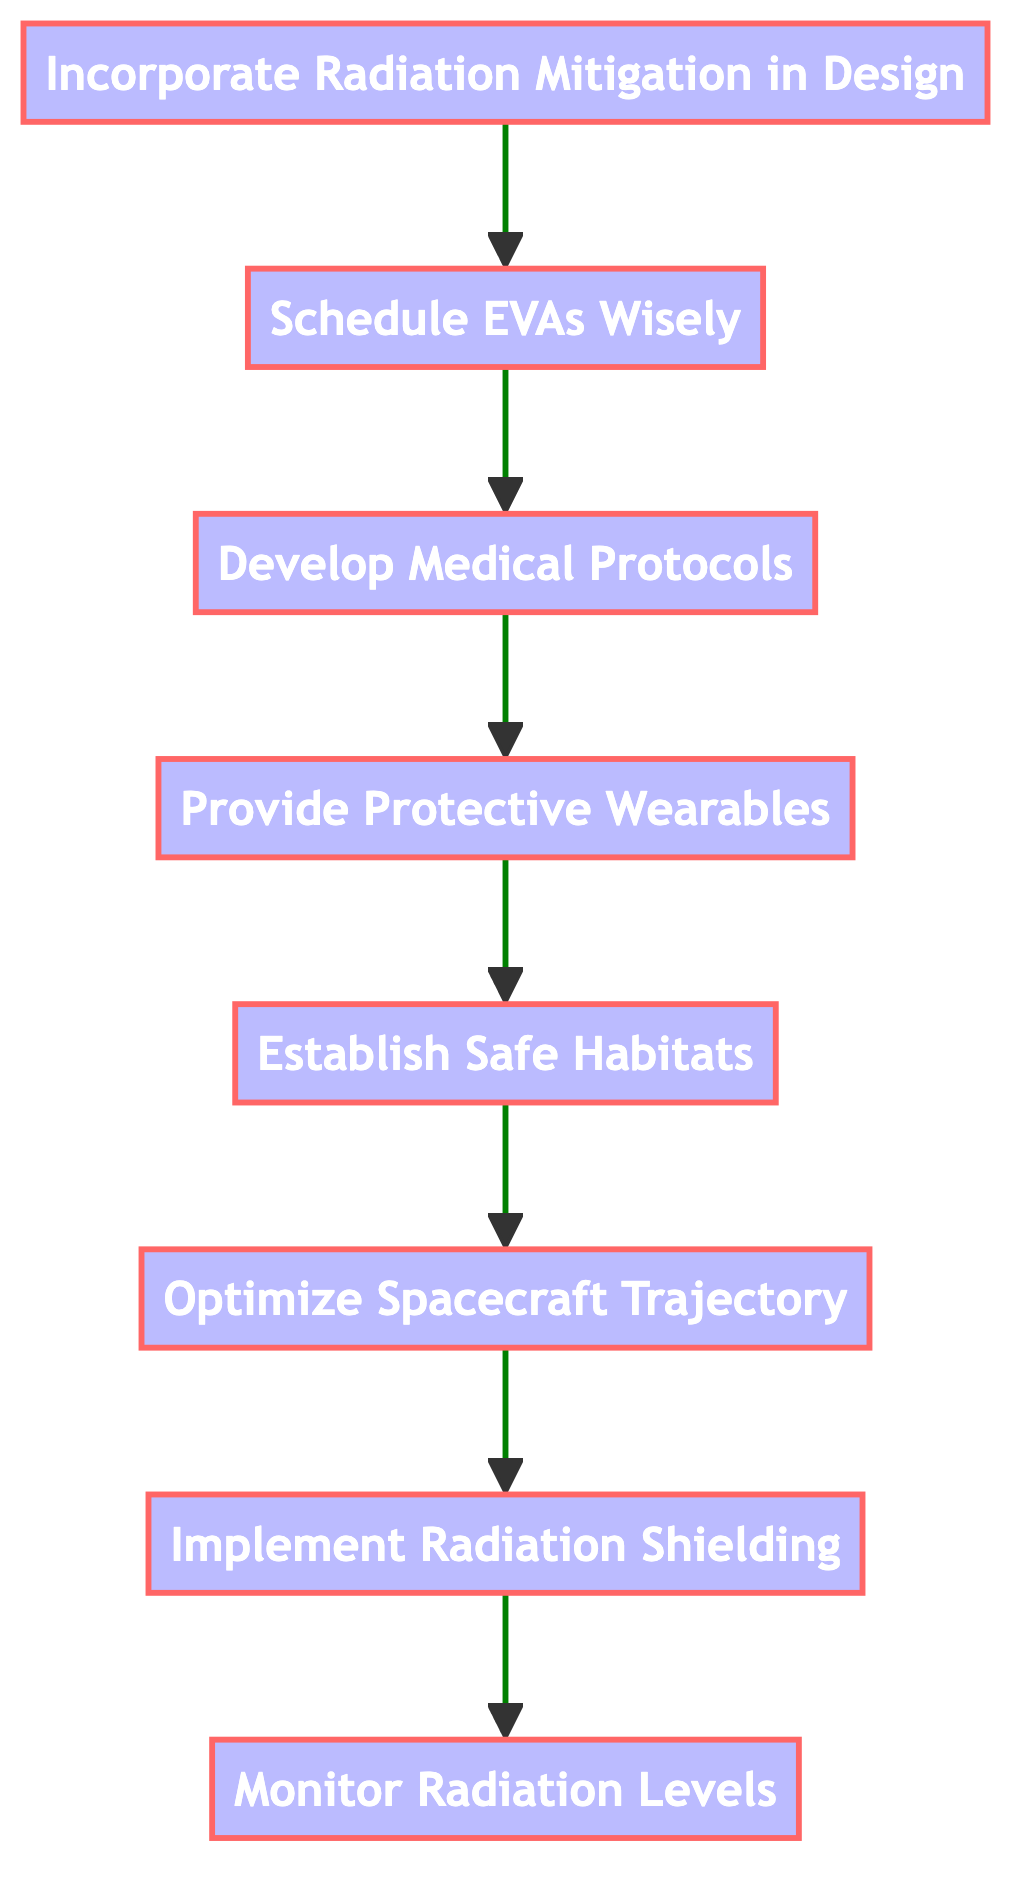What is the first step in mitigating radiation exposure? The diagram shows that the first step at the bottom is "Monitor Radiation Levels." This is indicated by its position as the starting node in the flowchart.
Answer: Monitor Radiation Levels How many total actions are specified in the diagram? The flowchart contains eight actions listed from "Monitor Radiation Levels" to "Incorporate Radiation Mitigation in Design." Counting each unique action gives a total of eight actions.
Answer: Eight Which step follows "Schedule Extravehicular Activities (EVAs) Wisely"? The diagram indicates that "Schedule EVAs Wisely" directly leads to the next step, which is "Develop Medical Protocols." This can be confirmed by examining the arrows connecting the nodes.
Answer: Develop Medical Protocols What is the last step in the flowchart? The diagram culminates with "Incorporate Radiation Mitigation in Design," which is the top node in this bottom-to-up flowchart, denoting that it is the final action to be taken in radiation exposure mitigation.
Answer: Incorporate Radiation Mitigation in Design How does "Establish Safe Habitats" relate to the overall process? "Establish Safe Habitats" is positioned in the middle of the flowchart, receiving input from "Provide Protective Wearables" and outputting to "Optimize Spacecraft Trajectory." This shows its role as an essential step that contributes to subsequent actions in the mitigation process.
Answer: It's a middle step contributing to subsequent actions 